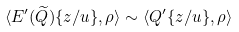Convert formula to latex. <formula><loc_0><loc_0><loc_500><loc_500>\langle E ^ { \prime } ( \widetilde { Q } ) \{ z / u \} , \rho \rangle \sim \langle Q ^ { \prime } \{ z / u \} , \rho \rangle</formula> 